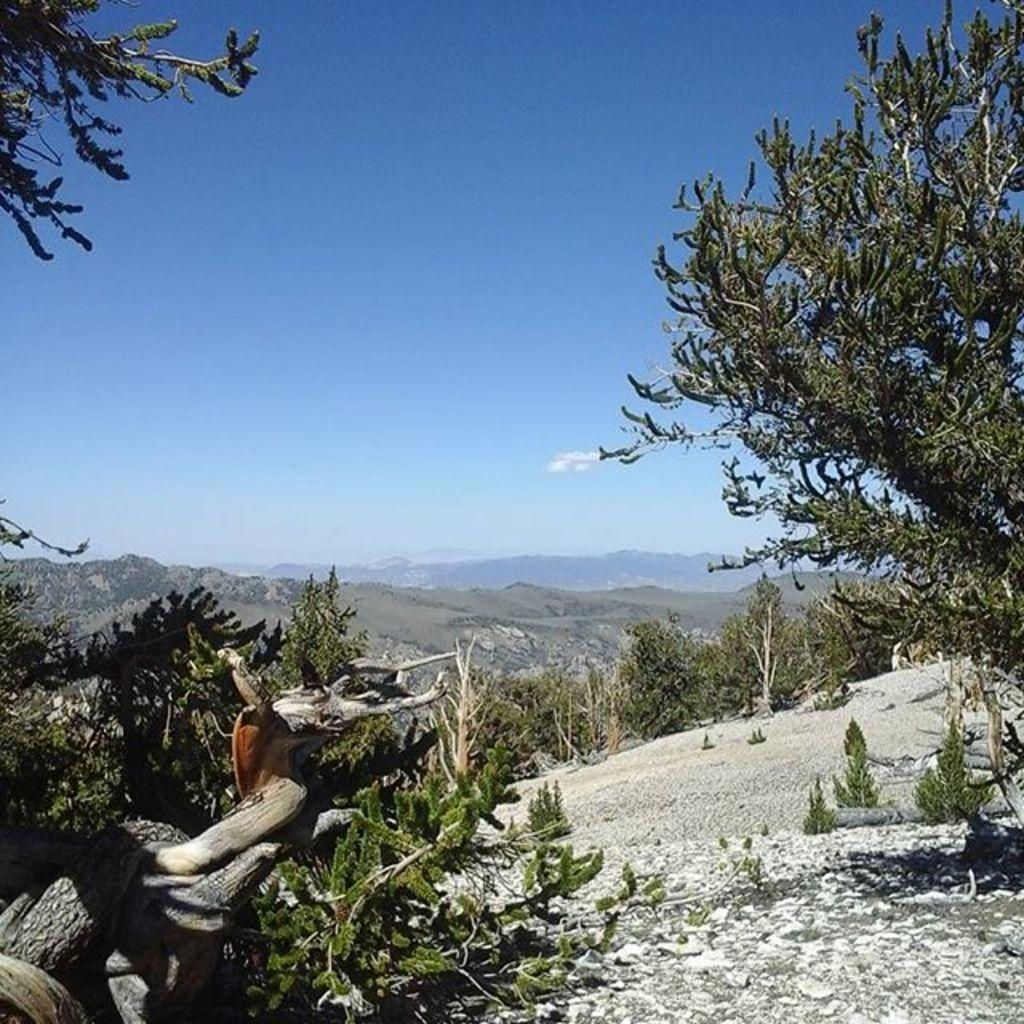What is the main object in the image? There is a branch in the image. What else can be seen in the image besides the branch? There are plants and trees in the image. What can be seen in the background of the image? Hills and the sky are visible in the background of the image. What type of note is being played by the tree in the image? There is no tree playing a note in the image; it features a branch, plants, trees, hills, and the sky. 